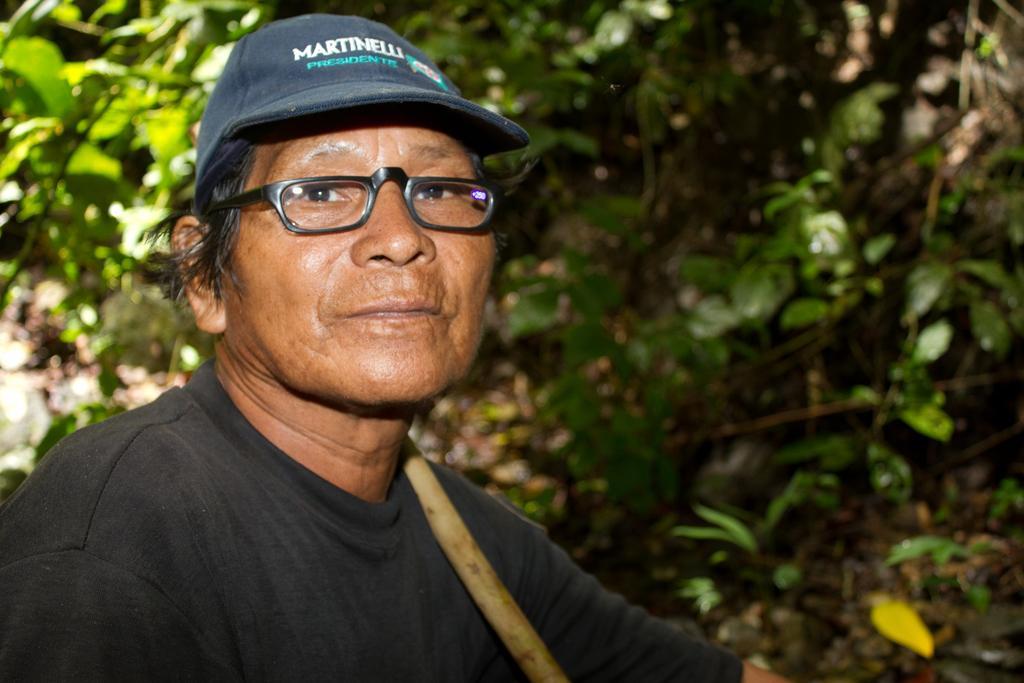Please provide a concise description of this image. In this image we can see a person with a cap. Behind the person we can see group of plants. 